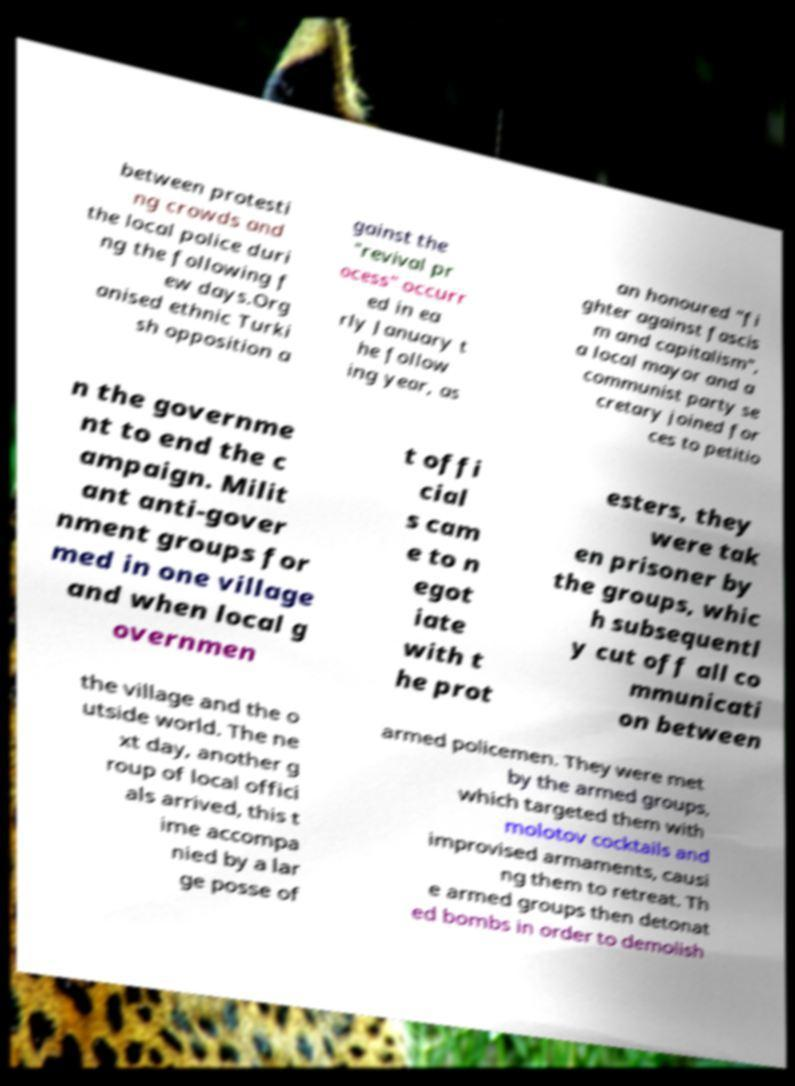Please read and relay the text visible in this image. What does it say? between protesti ng crowds and the local police duri ng the following f ew days.Org anised ethnic Turki sh opposition a gainst the "revival pr ocess" occurr ed in ea rly January t he follow ing year, as an honoured "fi ghter against fascis m and capitalism", a local mayor and a communist party se cretary joined for ces to petitio n the governme nt to end the c ampaign. Milit ant anti-gover nment groups for med in one village and when local g overnmen t offi cial s cam e to n egot iate with t he prot esters, they were tak en prisoner by the groups, whic h subsequentl y cut off all co mmunicati on between the village and the o utside world. The ne xt day, another g roup of local offici als arrived, this t ime accompa nied by a lar ge posse of armed policemen. They were met by the armed groups, which targeted them with molotov cocktails and improvised armaments, causi ng them to retreat. Th e armed groups then detonat ed bombs in order to demolish 